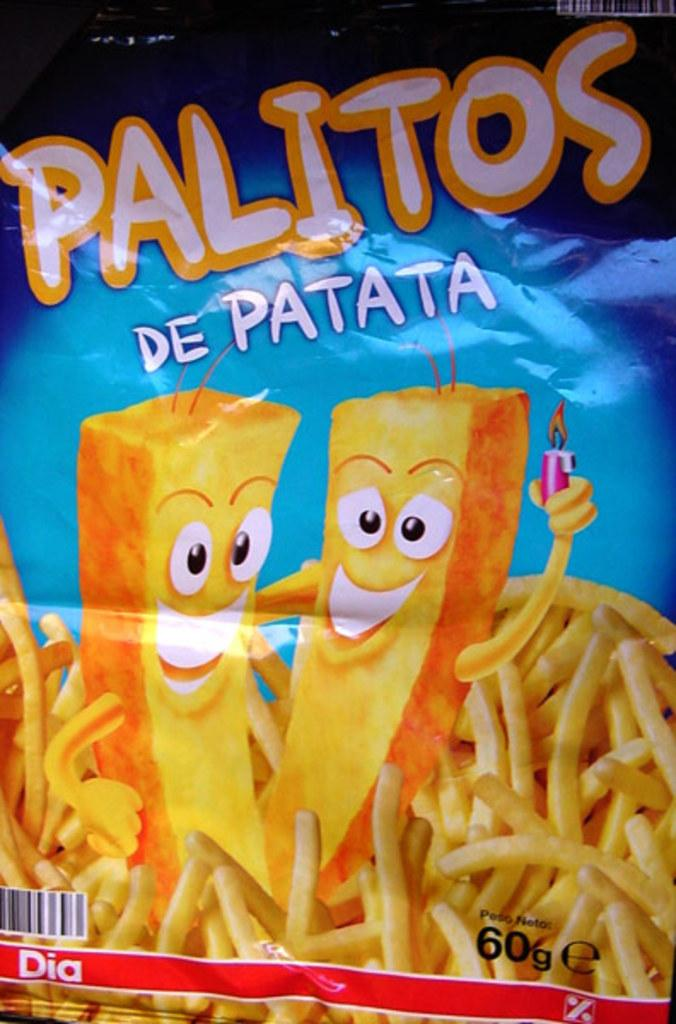What is the main object in the image? There is a plastic cover in the image. What can be seen on the plastic cover? The plastic cover has pictures and text printed on it. What type of vest is visible in the image? There is no vest present in the image; it only features a plastic cover with pictures and text. 